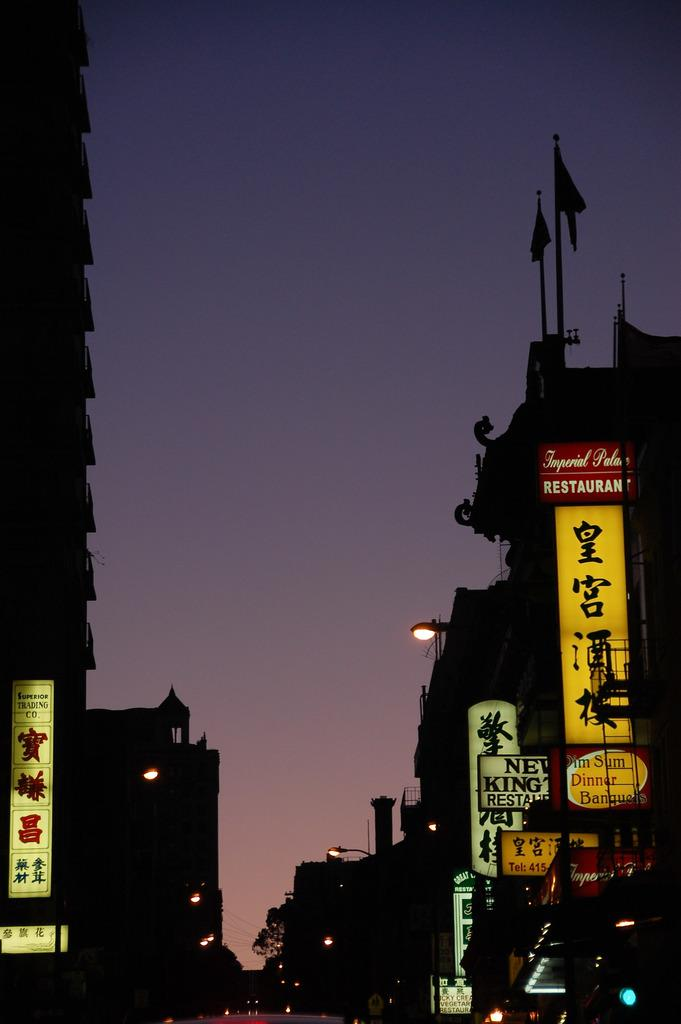Provide a one-sentence caption for the provided image. Imperial Palace restaurant is on the right and they serve dim sum. 